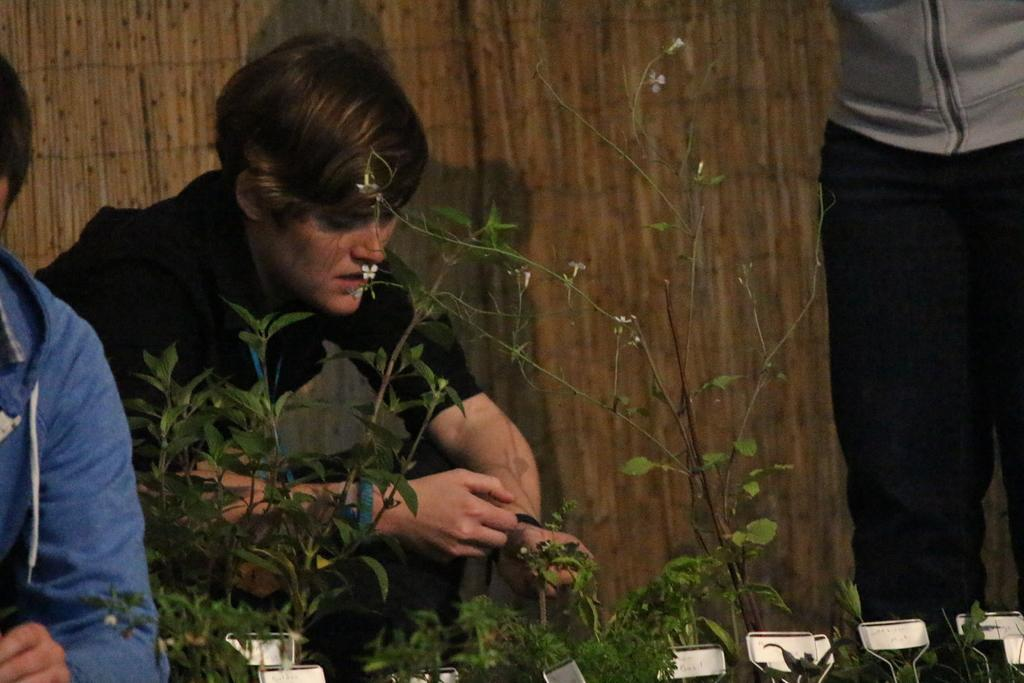How many people are in the image? There are three people in the image. What are the people doing in the image? One person is standing, while two are sitting. What can be seen in the image besides the people? There are plants and a tag in the image. Are the people wearing any clothing in the image? Yes, all three people are wearing clothes. What type of copper material can be seen in the image? There is no copper material present in the image. How much powder is visible on the sitting person's hands in the image? There is no powder visible on anyone's hands in the image. 